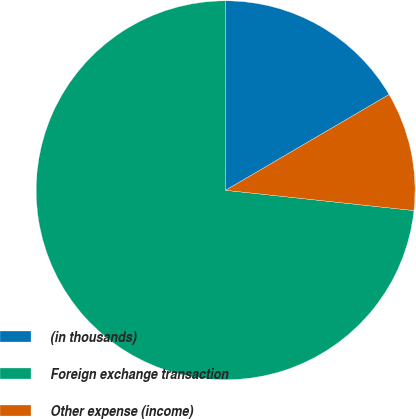<chart> <loc_0><loc_0><loc_500><loc_500><pie_chart><fcel>(in thousands)<fcel>Foreign exchange transaction<fcel>Other expense (income)<nl><fcel>16.57%<fcel>73.29%<fcel>10.14%<nl></chart> 